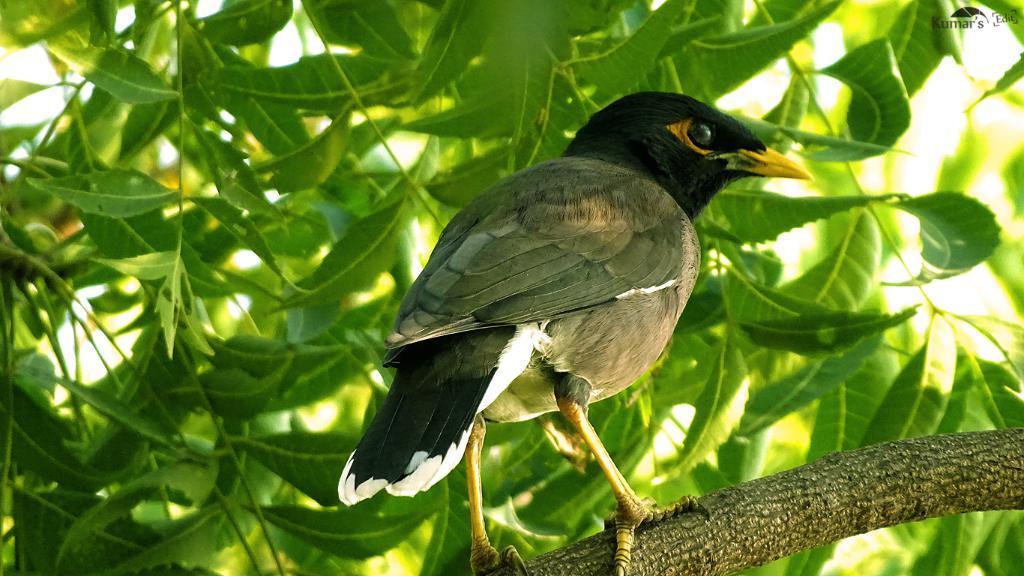Please provide a concise description of this image. In this picture we can see a bird on a tree branch and in the background we can see leaves, in the top right we can see some text on it. 